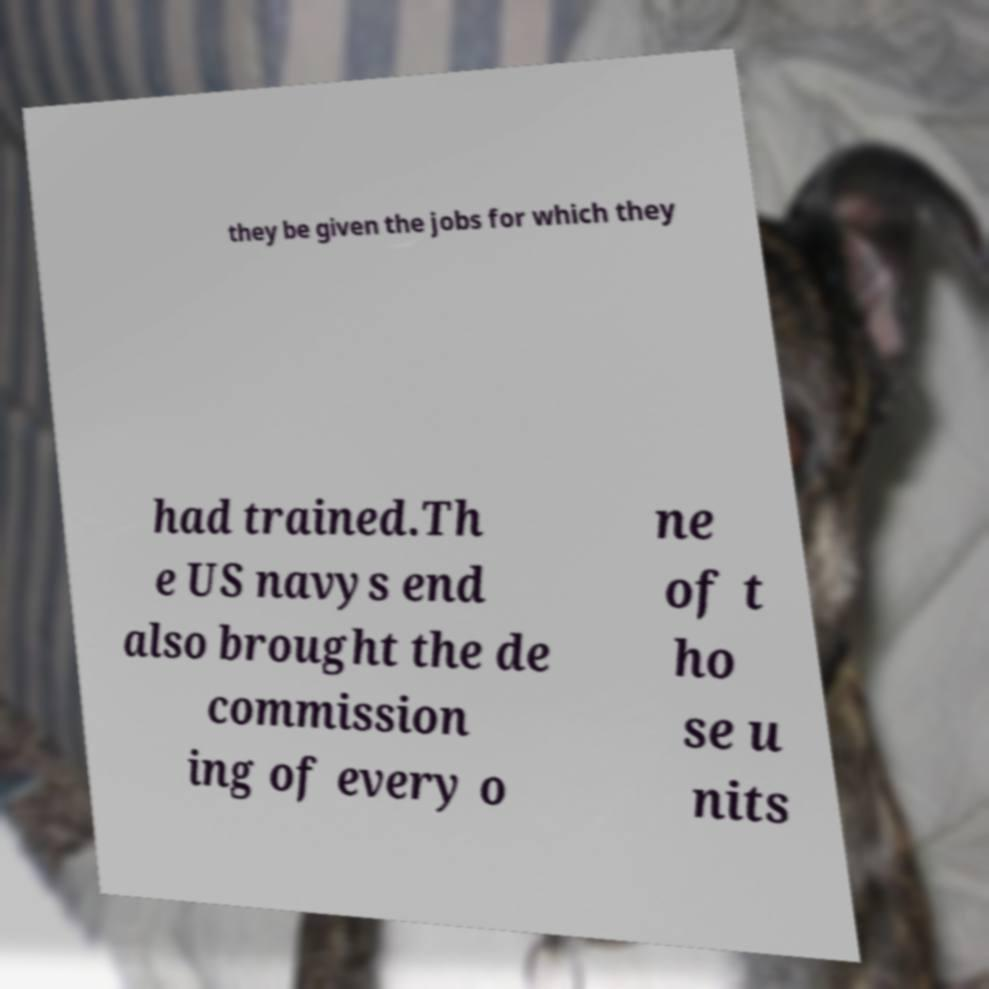Could you extract and type out the text from this image? they be given the jobs for which they had trained.Th e US navys end also brought the de commission ing of every o ne of t ho se u nits 